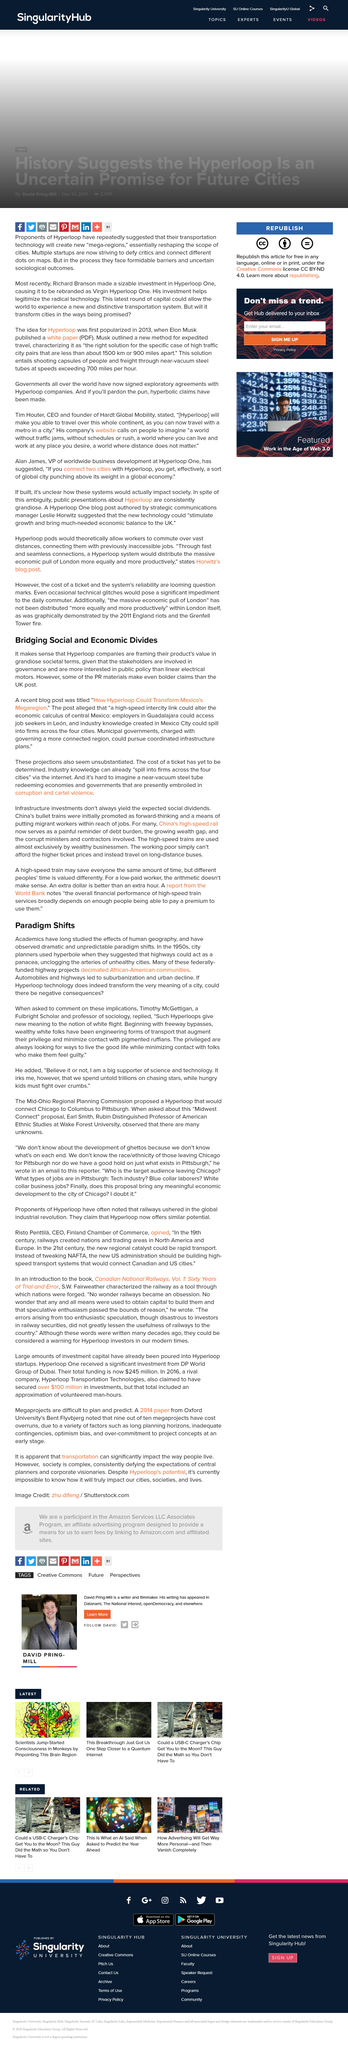Point out several critical features in this image. Timothy McGettigan is a Fulbright Scholar and a professor of sociology who is widely recognized for his contributions to the field. The development of automobiles and highways resulted in the widespread adoption of suburbanization and urban decline. PR materials make bolder claims than the UK post. The article is titled "Bridging Social and Economic Divides. Hyperloop companies are positioning their products as having the potential to significantly impact society and the recent blog post, titled "How Hyperloop Could Transform Mexico's Megareion...," explores the potential impact of Hyperloop in Mexico's megareion. 